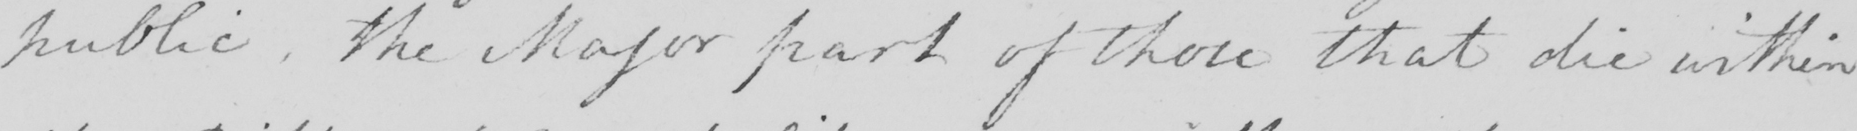Please provide the text content of this handwritten line. public , the Major part of those that die within 